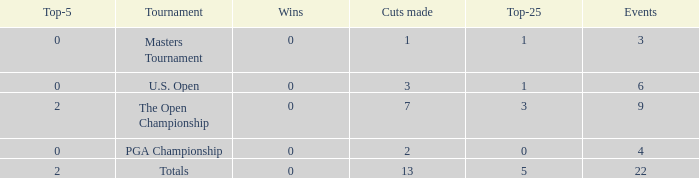What is the average number of cuts made for events with 0 top-5s? None. 